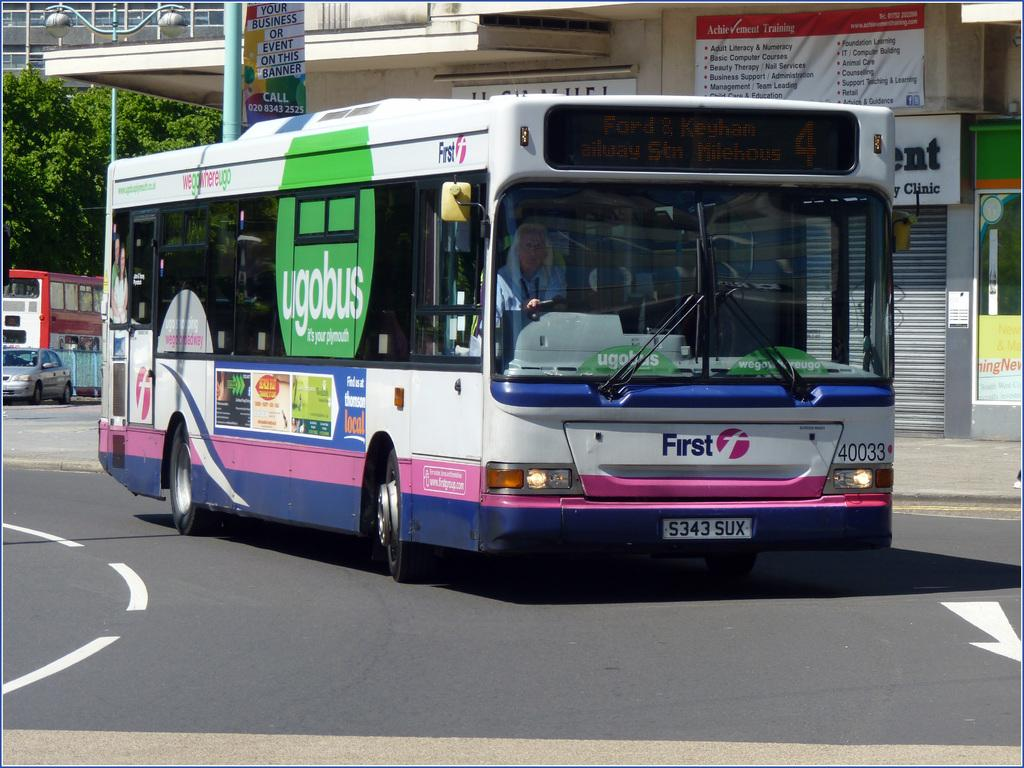<image>
Give a short and clear explanation of the subsequent image. Ugobus is advertised on the side of this public bus. 